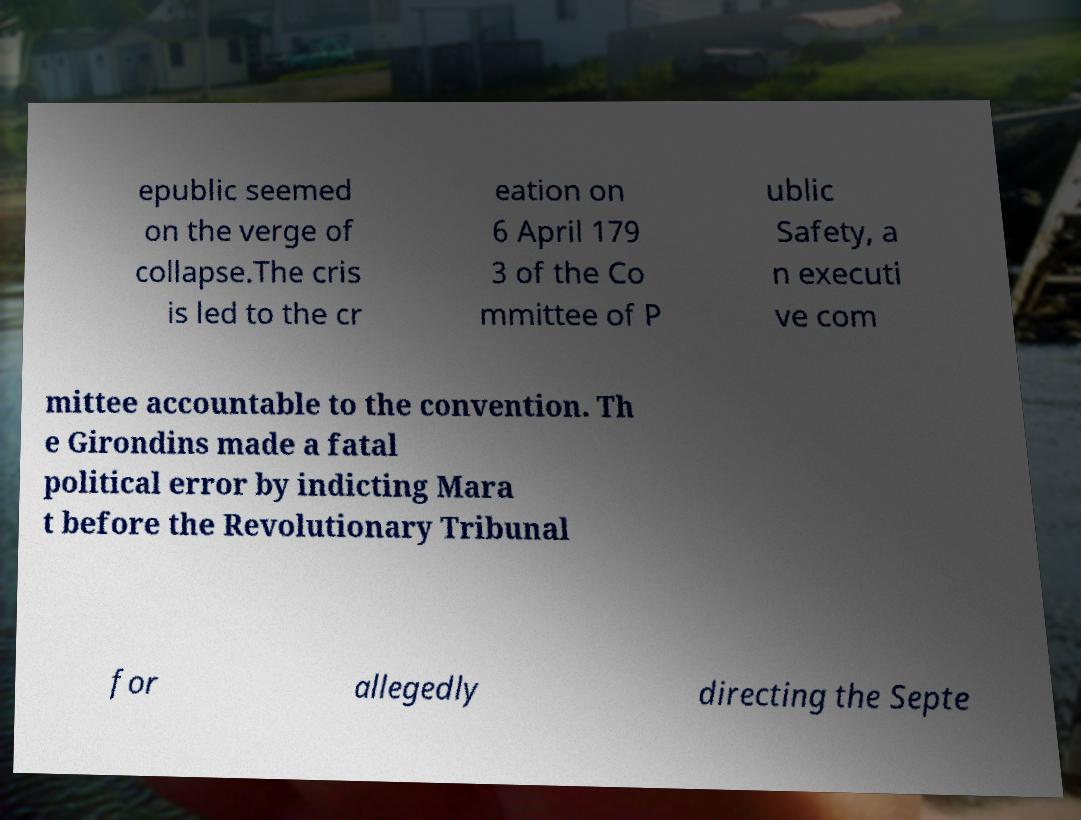Please read and relay the text visible in this image. What does it say? epublic seemed on the verge of collapse.The cris is led to the cr eation on 6 April 179 3 of the Co mmittee of P ublic Safety, a n executi ve com mittee accountable to the convention. Th e Girondins made a fatal political error by indicting Mara t before the Revolutionary Tribunal for allegedly directing the Septe 